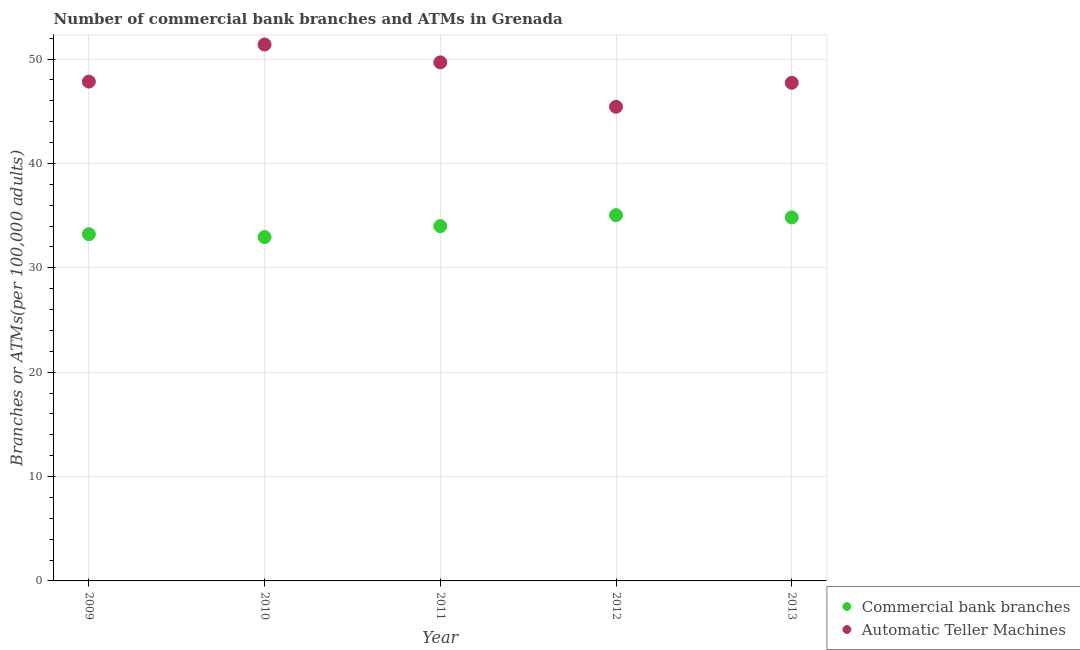How many different coloured dotlines are there?
Ensure brevity in your answer.  2. What is the number of commercal bank branches in 2009?
Your response must be concise. 33.22. Across all years, what is the maximum number of atms?
Your answer should be compact. 51.4. Across all years, what is the minimum number of commercal bank branches?
Give a very brief answer. 32.95. In which year was the number of atms maximum?
Offer a terse response. 2010. What is the total number of commercal bank branches in the graph?
Give a very brief answer. 170.04. What is the difference between the number of commercal bank branches in 2009 and that in 2010?
Offer a very short reply. 0.28. What is the difference between the number of commercal bank branches in 2011 and the number of atms in 2013?
Make the answer very short. -13.73. What is the average number of commercal bank branches per year?
Your answer should be compact. 34.01. In the year 2011, what is the difference between the number of commercal bank branches and number of atms?
Your response must be concise. -15.69. In how many years, is the number of commercal bank branches greater than 2?
Provide a succinct answer. 5. What is the ratio of the number of commercal bank branches in 2012 to that in 2013?
Your response must be concise. 1.01. Is the number of commercal bank branches in 2011 less than that in 2012?
Offer a terse response. Yes. What is the difference between the highest and the second highest number of commercal bank branches?
Offer a very short reply. 0.22. What is the difference between the highest and the lowest number of commercal bank branches?
Provide a succinct answer. 2.1. In how many years, is the number of atms greater than the average number of atms taken over all years?
Offer a very short reply. 2. Is the sum of the number of atms in 2009 and 2011 greater than the maximum number of commercal bank branches across all years?
Provide a succinct answer. Yes. Does the number of atms monotonically increase over the years?
Your answer should be compact. No. Is the number of commercal bank branches strictly less than the number of atms over the years?
Provide a short and direct response. Yes. How many dotlines are there?
Provide a short and direct response. 2. Are the values on the major ticks of Y-axis written in scientific E-notation?
Keep it short and to the point. No. Does the graph contain any zero values?
Your answer should be very brief. No. Does the graph contain grids?
Offer a terse response. Yes. How many legend labels are there?
Ensure brevity in your answer.  2. What is the title of the graph?
Ensure brevity in your answer.  Number of commercial bank branches and ATMs in Grenada. Does "Stunting" appear as one of the legend labels in the graph?
Provide a short and direct response. No. What is the label or title of the Y-axis?
Offer a terse response. Branches or ATMs(per 100,0 adults). What is the Branches or ATMs(per 100,000 adults) of Commercial bank branches in 2009?
Offer a terse response. 33.22. What is the Branches or ATMs(per 100,000 adults) of Automatic Teller Machines in 2009?
Offer a very short reply. 47.84. What is the Branches or ATMs(per 100,000 adults) in Commercial bank branches in 2010?
Offer a very short reply. 32.95. What is the Branches or ATMs(per 100,000 adults) in Automatic Teller Machines in 2010?
Offer a very short reply. 51.4. What is the Branches or ATMs(per 100,000 adults) of Commercial bank branches in 2011?
Give a very brief answer. 34. What is the Branches or ATMs(per 100,000 adults) of Automatic Teller Machines in 2011?
Offer a terse response. 49.69. What is the Branches or ATMs(per 100,000 adults) of Commercial bank branches in 2012?
Your answer should be compact. 35.05. What is the Branches or ATMs(per 100,000 adults) of Automatic Teller Machines in 2012?
Your answer should be compact. 45.43. What is the Branches or ATMs(per 100,000 adults) in Commercial bank branches in 2013?
Provide a succinct answer. 34.83. What is the Branches or ATMs(per 100,000 adults) in Automatic Teller Machines in 2013?
Your answer should be compact. 47.73. Across all years, what is the maximum Branches or ATMs(per 100,000 adults) in Commercial bank branches?
Offer a very short reply. 35.05. Across all years, what is the maximum Branches or ATMs(per 100,000 adults) of Automatic Teller Machines?
Offer a very short reply. 51.4. Across all years, what is the minimum Branches or ATMs(per 100,000 adults) of Commercial bank branches?
Keep it short and to the point. 32.95. Across all years, what is the minimum Branches or ATMs(per 100,000 adults) of Automatic Teller Machines?
Keep it short and to the point. 45.43. What is the total Branches or ATMs(per 100,000 adults) of Commercial bank branches in the graph?
Ensure brevity in your answer.  170.04. What is the total Branches or ATMs(per 100,000 adults) in Automatic Teller Machines in the graph?
Your answer should be compact. 242.09. What is the difference between the Branches or ATMs(per 100,000 adults) of Commercial bank branches in 2009 and that in 2010?
Give a very brief answer. 0.28. What is the difference between the Branches or ATMs(per 100,000 adults) of Automatic Teller Machines in 2009 and that in 2010?
Your answer should be compact. -3.55. What is the difference between the Branches or ATMs(per 100,000 adults) of Commercial bank branches in 2009 and that in 2011?
Make the answer very short. -0.77. What is the difference between the Branches or ATMs(per 100,000 adults) of Automatic Teller Machines in 2009 and that in 2011?
Give a very brief answer. -1.84. What is the difference between the Branches or ATMs(per 100,000 adults) of Commercial bank branches in 2009 and that in 2012?
Keep it short and to the point. -1.82. What is the difference between the Branches or ATMs(per 100,000 adults) in Automatic Teller Machines in 2009 and that in 2012?
Your answer should be compact. 2.41. What is the difference between the Branches or ATMs(per 100,000 adults) of Commercial bank branches in 2009 and that in 2013?
Your response must be concise. -1.61. What is the difference between the Branches or ATMs(per 100,000 adults) in Automatic Teller Machines in 2009 and that in 2013?
Your answer should be very brief. 0.11. What is the difference between the Branches or ATMs(per 100,000 adults) in Commercial bank branches in 2010 and that in 2011?
Offer a terse response. -1.05. What is the difference between the Branches or ATMs(per 100,000 adults) of Automatic Teller Machines in 2010 and that in 2011?
Provide a succinct answer. 1.71. What is the difference between the Branches or ATMs(per 100,000 adults) of Commercial bank branches in 2010 and that in 2012?
Ensure brevity in your answer.  -2.1. What is the difference between the Branches or ATMs(per 100,000 adults) in Automatic Teller Machines in 2010 and that in 2012?
Your response must be concise. 5.97. What is the difference between the Branches or ATMs(per 100,000 adults) of Commercial bank branches in 2010 and that in 2013?
Ensure brevity in your answer.  -1.88. What is the difference between the Branches or ATMs(per 100,000 adults) of Automatic Teller Machines in 2010 and that in 2013?
Give a very brief answer. 3.67. What is the difference between the Branches or ATMs(per 100,000 adults) of Commercial bank branches in 2011 and that in 2012?
Your response must be concise. -1.05. What is the difference between the Branches or ATMs(per 100,000 adults) in Automatic Teller Machines in 2011 and that in 2012?
Make the answer very short. 4.26. What is the difference between the Branches or ATMs(per 100,000 adults) of Commercial bank branches in 2011 and that in 2013?
Give a very brief answer. -0.83. What is the difference between the Branches or ATMs(per 100,000 adults) of Automatic Teller Machines in 2011 and that in 2013?
Ensure brevity in your answer.  1.96. What is the difference between the Branches or ATMs(per 100,000 adults) in Commercial bank branches in 2012 and that in 2013?
Your answer should be very brief. 0.22. What is the difference between the Branches or ATMs(per 100,000 adults) of Automatic Teller Machines in 2012 and that in 2013?
Your answer should be very brief. -2.3. What is the difference between the Branches or ATMs(per 100,000 adults) in Commercial bank branches in 2009 and the Branches or ATMs(per 100,000 adults) in Automatic Teller Machines in 2010?
Your response must be concise. -18.17. What is the difference between the Branches or ATMs(per 100,000 adults) in Commercial bank branches in 2009 and the Branches or ATMs(per 100,000 adults) in Automatic Teller Machines in 2011?
Make the answer very short. -16.46. What is the difference between the Branches or ATMs(per 100,000 adults) of Commercial bank branches in 2009 and the Branches or ATMs(per 100,000 adults) of Automatic Teller Machines in 2012?
Your answer should be compact. -12.21. What is the difference between the Branches or ATMs(per 100,000 adults) in Commercial bank branches in 2009 and the Branches or ATMs(per 100,000 adults) in Automatic Teller Machines in 2013?
Make the answer very short. -14.51. What is the difference between the Branches or ATMs(per 100,000 adults) in Commercial bank branches in 2010 and the Branches or ATMs(per 100,000 adults) in Automatic Teller Machines in 2011?
Make the answer very short. -16.74. What is the difference between the Branches or ATMs(per 100,000 adults) of Commercial bank branches in 2010 and the Branches or ATMs(per 100,000 adults) of Automatic Teller Machines in 2012?
Your answer should be compact. -12.48. What is the difference between the Branches or ATMs(per 100,000 adults) in Commercial bank branches in 2010 and the Branches or ATMs(per 100,000 adults) in Automatic Teller Machines in 2013?
Give a very brief answer. -14.78. What is the difference between the Branches or ATMs(per 100,000 adults) of Commercial bank branches in 2011 and the Branches or ATMs(per 100,000 adults) of Automatic Teller Machines in 2012?
Your answer should be very brief. -11.44. What is the difference between the Branches or ATMs(per 100,000 adults) of Commercial bank branches in 2011 and the Branches or ATMs(per 100,000 adults) of Automatic Teller Machines in 2013?
Your answer should be very brief. -13.73. What is the difference between the Branches or ATMs(per 100,000 adults) of Commercial bank branches in 2012 and the Branches or ATMs(per 100,000 adults) of Automatic Teller Machines in 2013?
Provide a succinct answer. -12.68. What is the average Branches or ATMs(per 100,000 adults) in Commercial bank branches per year?
Ensure brevity in your answer.  34.01. What is the average Branches or ATMs(per 100,000 adults) of Automatic Teller Machines per year?
Offer a terse response. 48.42. In the year 2009, what is the difference between the Branches or ATMs(per 100,000 adults) of Commercial bank branches and Branches or ATMs(per 100,000 adults) of Automatic Teller Machines?
Offer a very short reply. -14.62. In the year 2010, what is the difference between the Branches or ATMs(per 100,000 adults) of Commercial bank branches and Branches or ATMs(per 100,000 adults) of Automatic Teller Machines?
Give a very brief answer. -18.45. In the year 2011, what is the difference between the Branches or ATMs(per 100,000 adults) in Commercial bank branches and Branches or ATMs(per 100,000 adults) in Automatic Teller Machines?
Give a very brief answer. -15.69. In the year 2012, what is the difference between the Branches or ATMs(per 100,000 adults) of Commercial bank branches and Branches or ATMs(per 100,000 adults) of Automatic Teller Machines?
Ensure brevity in your answer.  -10.38. In the year 2013, what is the difference between the Branches or ATMs(per 100,000 adults) in Commercial bank branches and Branches or ATMs(per 100,000 adults) in Automatic Teller Machines?
Your answer should be compact. -12.9. What is the ratio of the Branches or ATMs(per 100,000 adults) in Commercial bank branches in 2009 to that in 2010?
Offer a very short reply. 1.01. What is the ratio of the Branches or ATMs(per 100,000 adults) in Automatic Teller Machines in 2009 to that in 2010?
Ensure brevity in your answer.  0.93. What is the ratio of the Branches or ATMs(per 100,000 adults) of Commercial bank branches in 2009 to that in 2011?
Ensure brevity in your answer.  0.98. What is the ratio of the Branches or ATMs(per 100,000 adults) of Automatic Teller Machines in 2009 to that in 2011?
Your answer should be compact. 0.96. What is the ratio of the Branches or ATMs(per 100,000 adults) of Commercial bank branches in 2009 to that in 2012?
Offer a very short reply. 0.95. What is the ratio of the Branches or ATMs(per 100,000 adults) in Automatic Teller Machines in 2009 to that in 2012?
Give a very brief answer. 1.05. What is the ratio of the Branches or ATMs(per 100,000 adults) in Commercial bank branches in 2009 to that in 2013?
Provide a short and direct response. 0.95. What is the ratio of the Branches or ATMs(per 100,000 adults) in Commercial bank branches in 2010 to that in 2011?
Your response must be concise. 0.97. What is the ratio of the Branches or ATMs(per 100,000 adults) of Automatic Teller Machines in 2010 to that in 2011?
Ensure brevity in your answer.  1.03. What is the ratio of the Branches or ATMs(per 100,000 adults) in Commercial bank branches in 2010 to that in 2012?
Offer a terse response. 0.94. What is the ratio of the Branches or ATMs(per 100,000 adults) of Automatic Teller Machines in 2010 to that in 2012?
Give a very brief answer. 1.13. What is the ratio of the Branches or ATMs(per 100,000 adults) in Commercial bank branches in 2010 to that in 2013?
Make the answer very short. 0.95. What is the ratio of the Branches or ATMs(per 100,000 adults) in Automatic Teller Machines in 2010 to that in 2013?
Offer a very short reply. 1.08. What is the ratio of the Branches or ATMs(per 100,000 adults) of Commercial bank branches in 2011 to that in 2012?
Give a very brief answer. 0.97. What is the ratio of the Branches or ATMs(per 100,000 adults) in Automatic Teller Machines in 2011 to that in 2012?
Make the answer very short. 1.09. What is the ratio of the Branches or ATMs(per 100,000 adults) in Automatic Teller Machines in 2011 to that in 2013?
Keep it short and to the point. 1.04. What is the ratio of the Branches or ATMs(per 100,000 adults) of Automatic Teller Machines in 2012 to that in 2013?
Your answer should be compact. 0.95. What is the difference between the highest and the second highest Branches or ATMs(per 100,000 adults) of Commercial bank branches?
Ensure brevity in your answer.  0.22. What is the difference between the highest and the second highest Branches or ATMs(per 100,000 adults) in Automatic Teller Machines?
Provide a short and direct response. 1.71. What is the difference between the highest and the lowest Branches or ATMs(per 100,000 adults) of Commercial bank branches?
Your answer should be very brief. 2.1. What is the difference between the highest and the lowest Branches or ATMs(per 100,000 adults) in Automatic Teller Machines?
Ensure brevity in your answer.  5.97. 